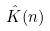<formula> <loc_0><loc_0><loc_500><loc_500>\hat { K } ( n )</formula> 